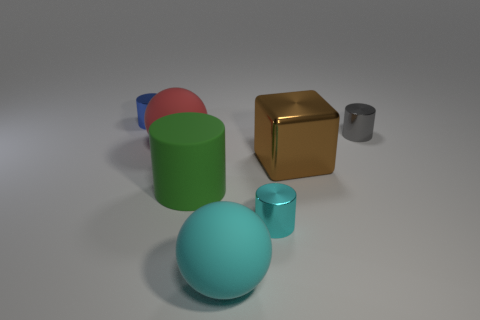There is a green thing that is the same size as the cyan matte ball; what is its material?
Give a very brief answer. Rubber. Is there a green thing made of the same material as the big red ball?
Give a very brief answer. Yes. What is the color of the small cylinder that is both behind the metallic block and left of the gray metal object?
Your response must be concise. Blue. How many other things are there of the same color as the big shiny block?
Your answer should be compact. 0. There is a tiny cylinder in front of the big sphere that is on the left side of the matte sphere in front of the large brown shiny block; what is its material?
Your response must be concise. Metal. How many spheres are yellow shiny things or big objects?
Your answer should be very brief. 2. Are there any other things that have the same size as the gray metallic object?
Offer a terse response. Yes. There is a large rubber sphere that is behind the tiny cylinder in front of the red ball; how many matte cylinders are in front of it?
Provide a short and direct response. 1. Is the shape of the small cyan object the same as the big red object?
Your response must be concise. No. Is the material of the block behind the tiny cyan object the same as the cylinder that is in front of the green matte cylinder?
Make the answer very short. Yes. 